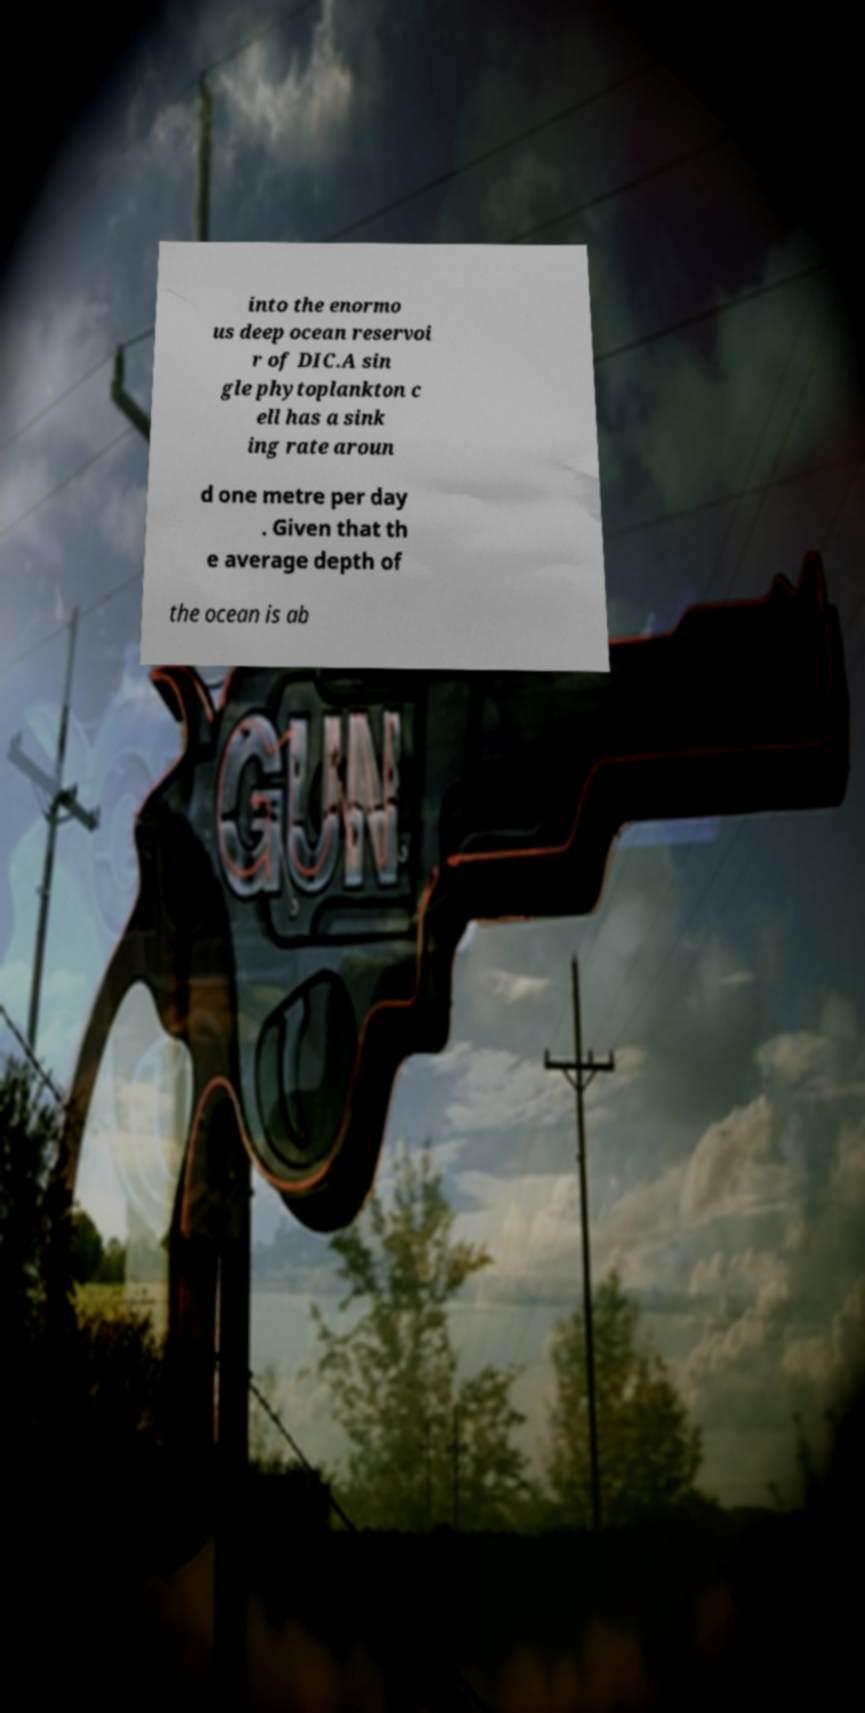Please read and relay the text visible in this image. What does it say? into the enormo us deep ocean reservoi r of DIC.A sin gle phytoplankton c ell has a sink ing rate aroun d one metre per day . Given that th e average depth of the ocean is ab 